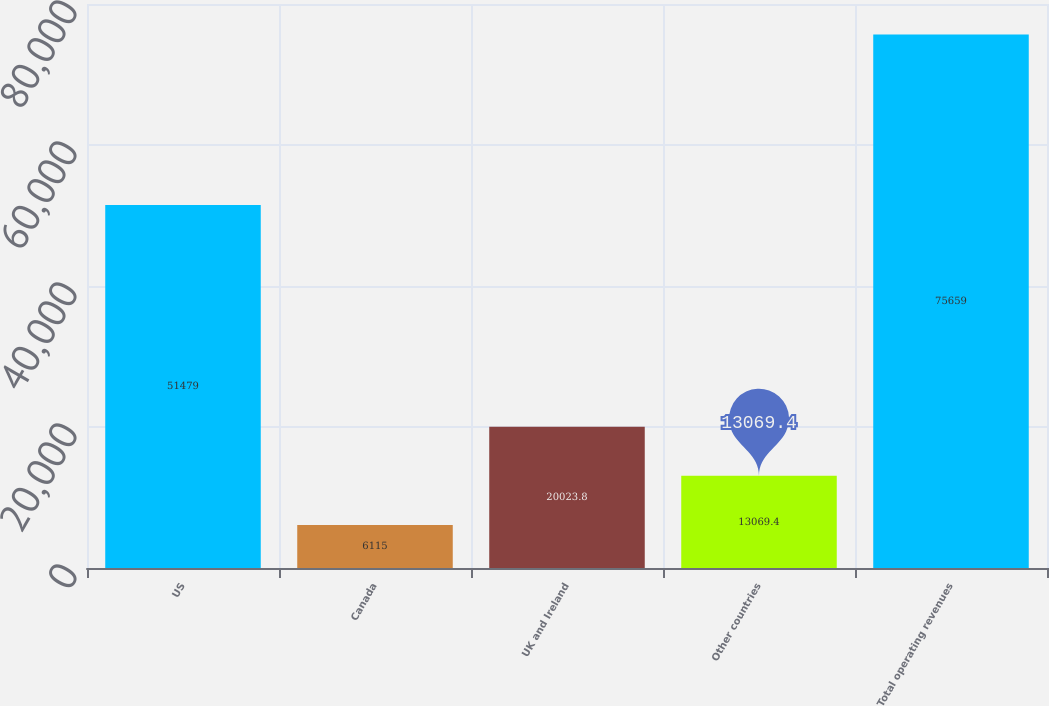<chart> <loc_0><loc_0><loc_500><loc_500><bar_chart><fcel>US<fcel>Canada<fcel>UK and Ireland<fcel>Other countries<fcel>Total operating revenues<nl><fcel>51479<fcel>6115<fcel>20023.8<fcel>13069.4<fcel>75659<nl></chart> 